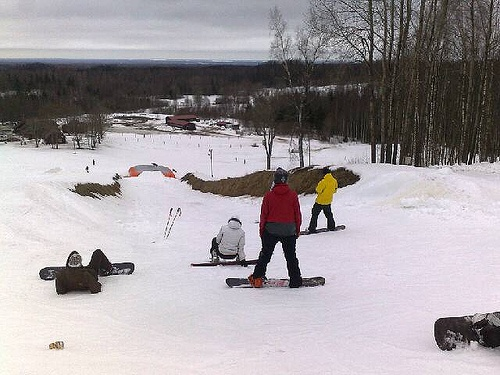Describe the objects in this image and their specific colors. I can see people in lightgray, black, maroon, and gray tones, people in lightgray, black, gray, and darkgray tones, snowboard in lightgray, black, gray, and darkgray tones, people in lightgray, darkgray, black, gray, and lavender tones, and people in lightgray, black, olive, and gray tones in this image. 